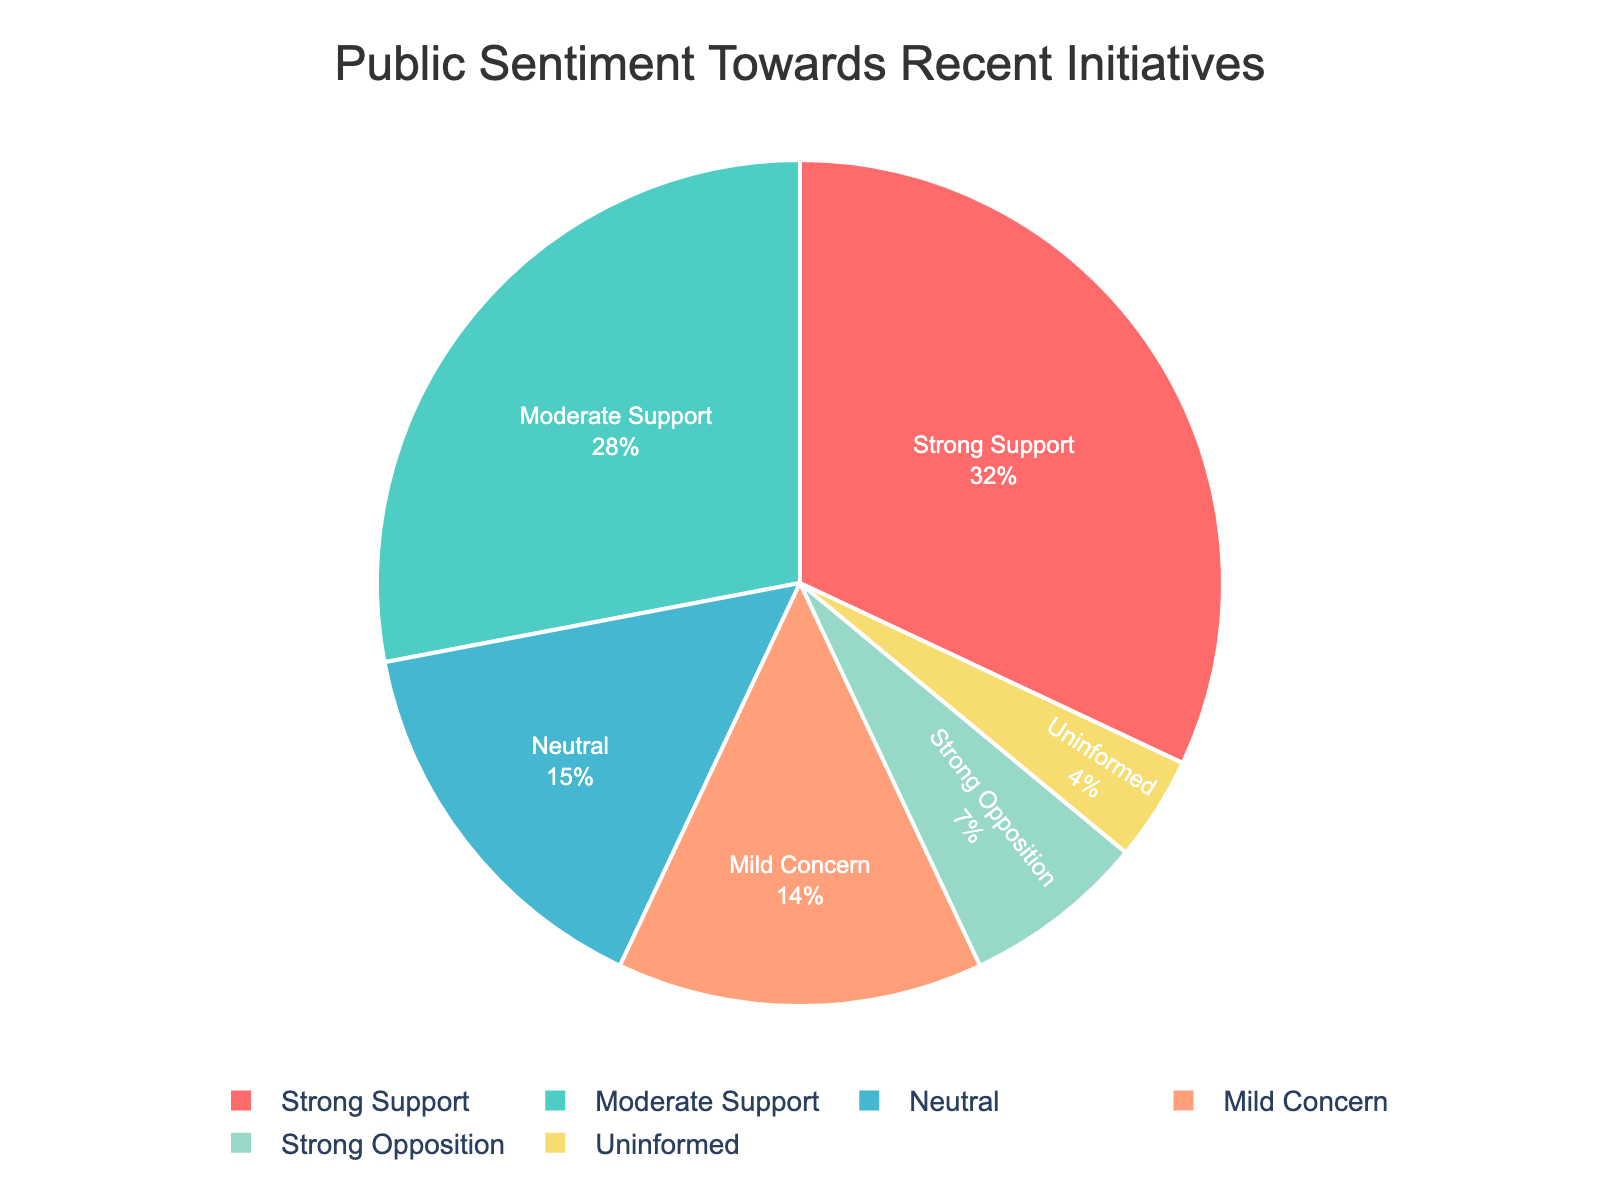What percentage of sentiment is either Strong Support or Moderate Support? Adding the percentages of Strong Support (32%) and Moderate Support (28%) gives us 32 + 28 = 60.
Answer: 60% How does the percentage of Neutral sentiment compare to Mild Concern? Neutral sentiment is at 15%, while Mild Concern is at 14%. 15% is slightly higher than 14%.
Answer: Neutral is higher Which sentiment category has the lowest percentage? Referring to the figure, the Uninformed category has the lowest percentage at 4%.
Answer: Uninformed What is the combined percentage of Negative Sentiments (Mild Concern and Strong Opposition)? Adding the percentages of Mild Concern (14%) and Strong Opposition (7%) gives us 14 + 7 = 21.
Answer: 21% Is Neutral sentiment more than half of Moderate Support? Moderate Support is 28%. Half of that is 28/2 = 14. Since Neutral is 15%, which is more than 14, Neutral sentiment is more than half of Moderate Support.
Answer: Yes How much more support (Strong Support and Moderate Support) is there compared to opposition (Mild Concern and Strong Opposition)? The combined support is 32% + 28% = 60%. The combined opposition is 14% + 7% = 21%. The difference between them is 60 - 21 = 39.
Answer: 39% Which color represents the Strong Opposition sentiment? Referring to the visual attributes of the pie chart, the Strong Opposition segment is represented by a red color.
Answer: Red Are there more people with Strong Support than the total of Neutral and Uninformed combined? Adding Neutral (15%) and Uninformed (4%) gives us 15 + 4 = 19%. Since Strong Support is 32%, 32% is more than 19%.
Answer: Yes What's the percentage difference between Strong Support and Moderate Support? The Strong Support percentage is 32% and the Moderate Support percentage is 28%. The difference is 32 - 28 = 4.
Answer: 4% What is the average percentage of all sentiment categories? Adding all percentages: 32 + 28 + 15 + 14 + 7 + 4 = 100%. Since there are 6 categories, the average is 100/6 ≈ 16.67.
Answer: 16.67% 